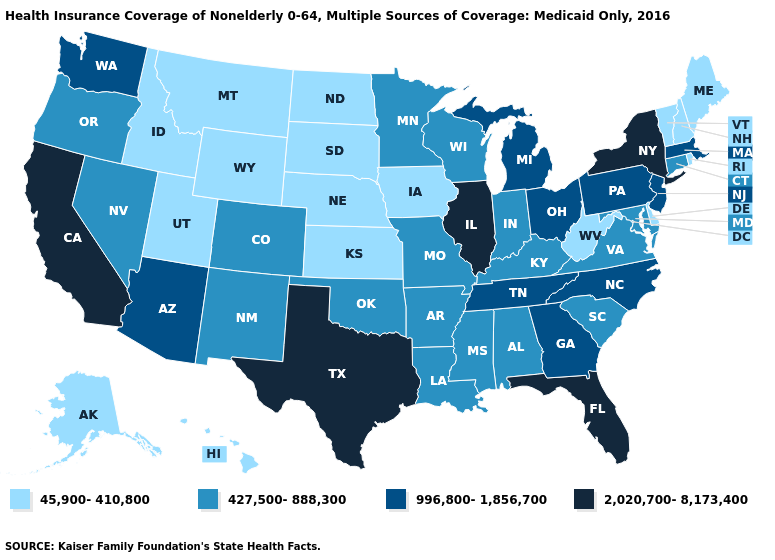What is the lowest value in the South?
Write a very short answer. 45,900-410,800. Does Illinois have the highest value in the MidWest?
Be succinct. Yes. Which states have the highest value in the USA?
Quick response, please. California, Florida, Illinois, New York, Texas. Name the states that have a value in the range 45,900-410,800?
Quick response, please. Alaska, Delaware, Hawaii, Idaho, Iowa, Kansas, Maine, Montana, Nebraska, New Hampshire, North Dakota, Rhode Island, South Dakota, Utah, Vermont, West Virginia, Wyoming. What is the value of North Dakota?
Write a very short answer. 45,900-410,800. What is the lowest value in the West?
Write a very short answer. 45,900-410,800. What is the value of Oregon?
Quick response, please. 427,500-888,300. Does Iowa have a higher value than Rhode Island?
Answer briefly. No. What is the value of Nebraska?
Concise answer only. 45,900-410,800. Among the states that border Illinois , which have the lowest value?
Short answer required. Iowa. What is the value of Vermont?
Be succinct. 45,900-410,800. What is the lowest value in the USA?
Answer briefly. 45,900-410,800. Does Minnesota have a higher value than Alabama?
Short answer required. No. What is the lowest value in states that border Washington?
Keep it brief. 45,900-410,800. 